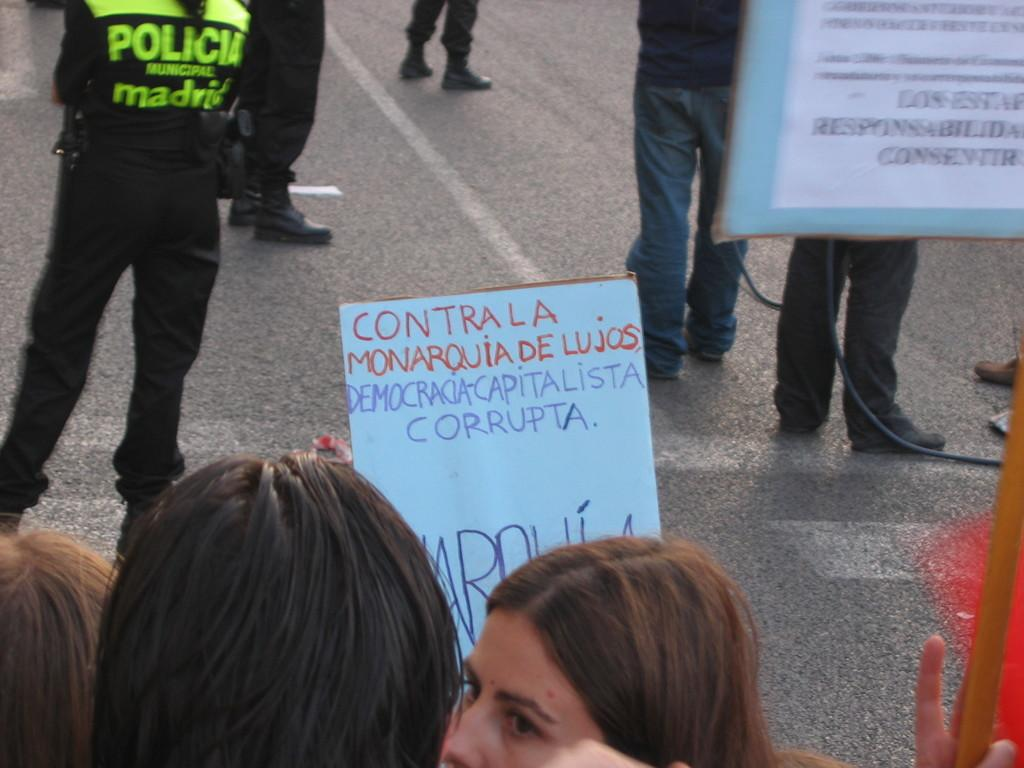Who or what can be seen in the image? There are people in the image. Where are the people located? The people are standing on the road. What are the people holding in the image? The people are holding placards. How many bikes are parked next to the people in the image? There are no bikes present in the image. What type of van can be seen in the background of the image? There is no van present in the image. 